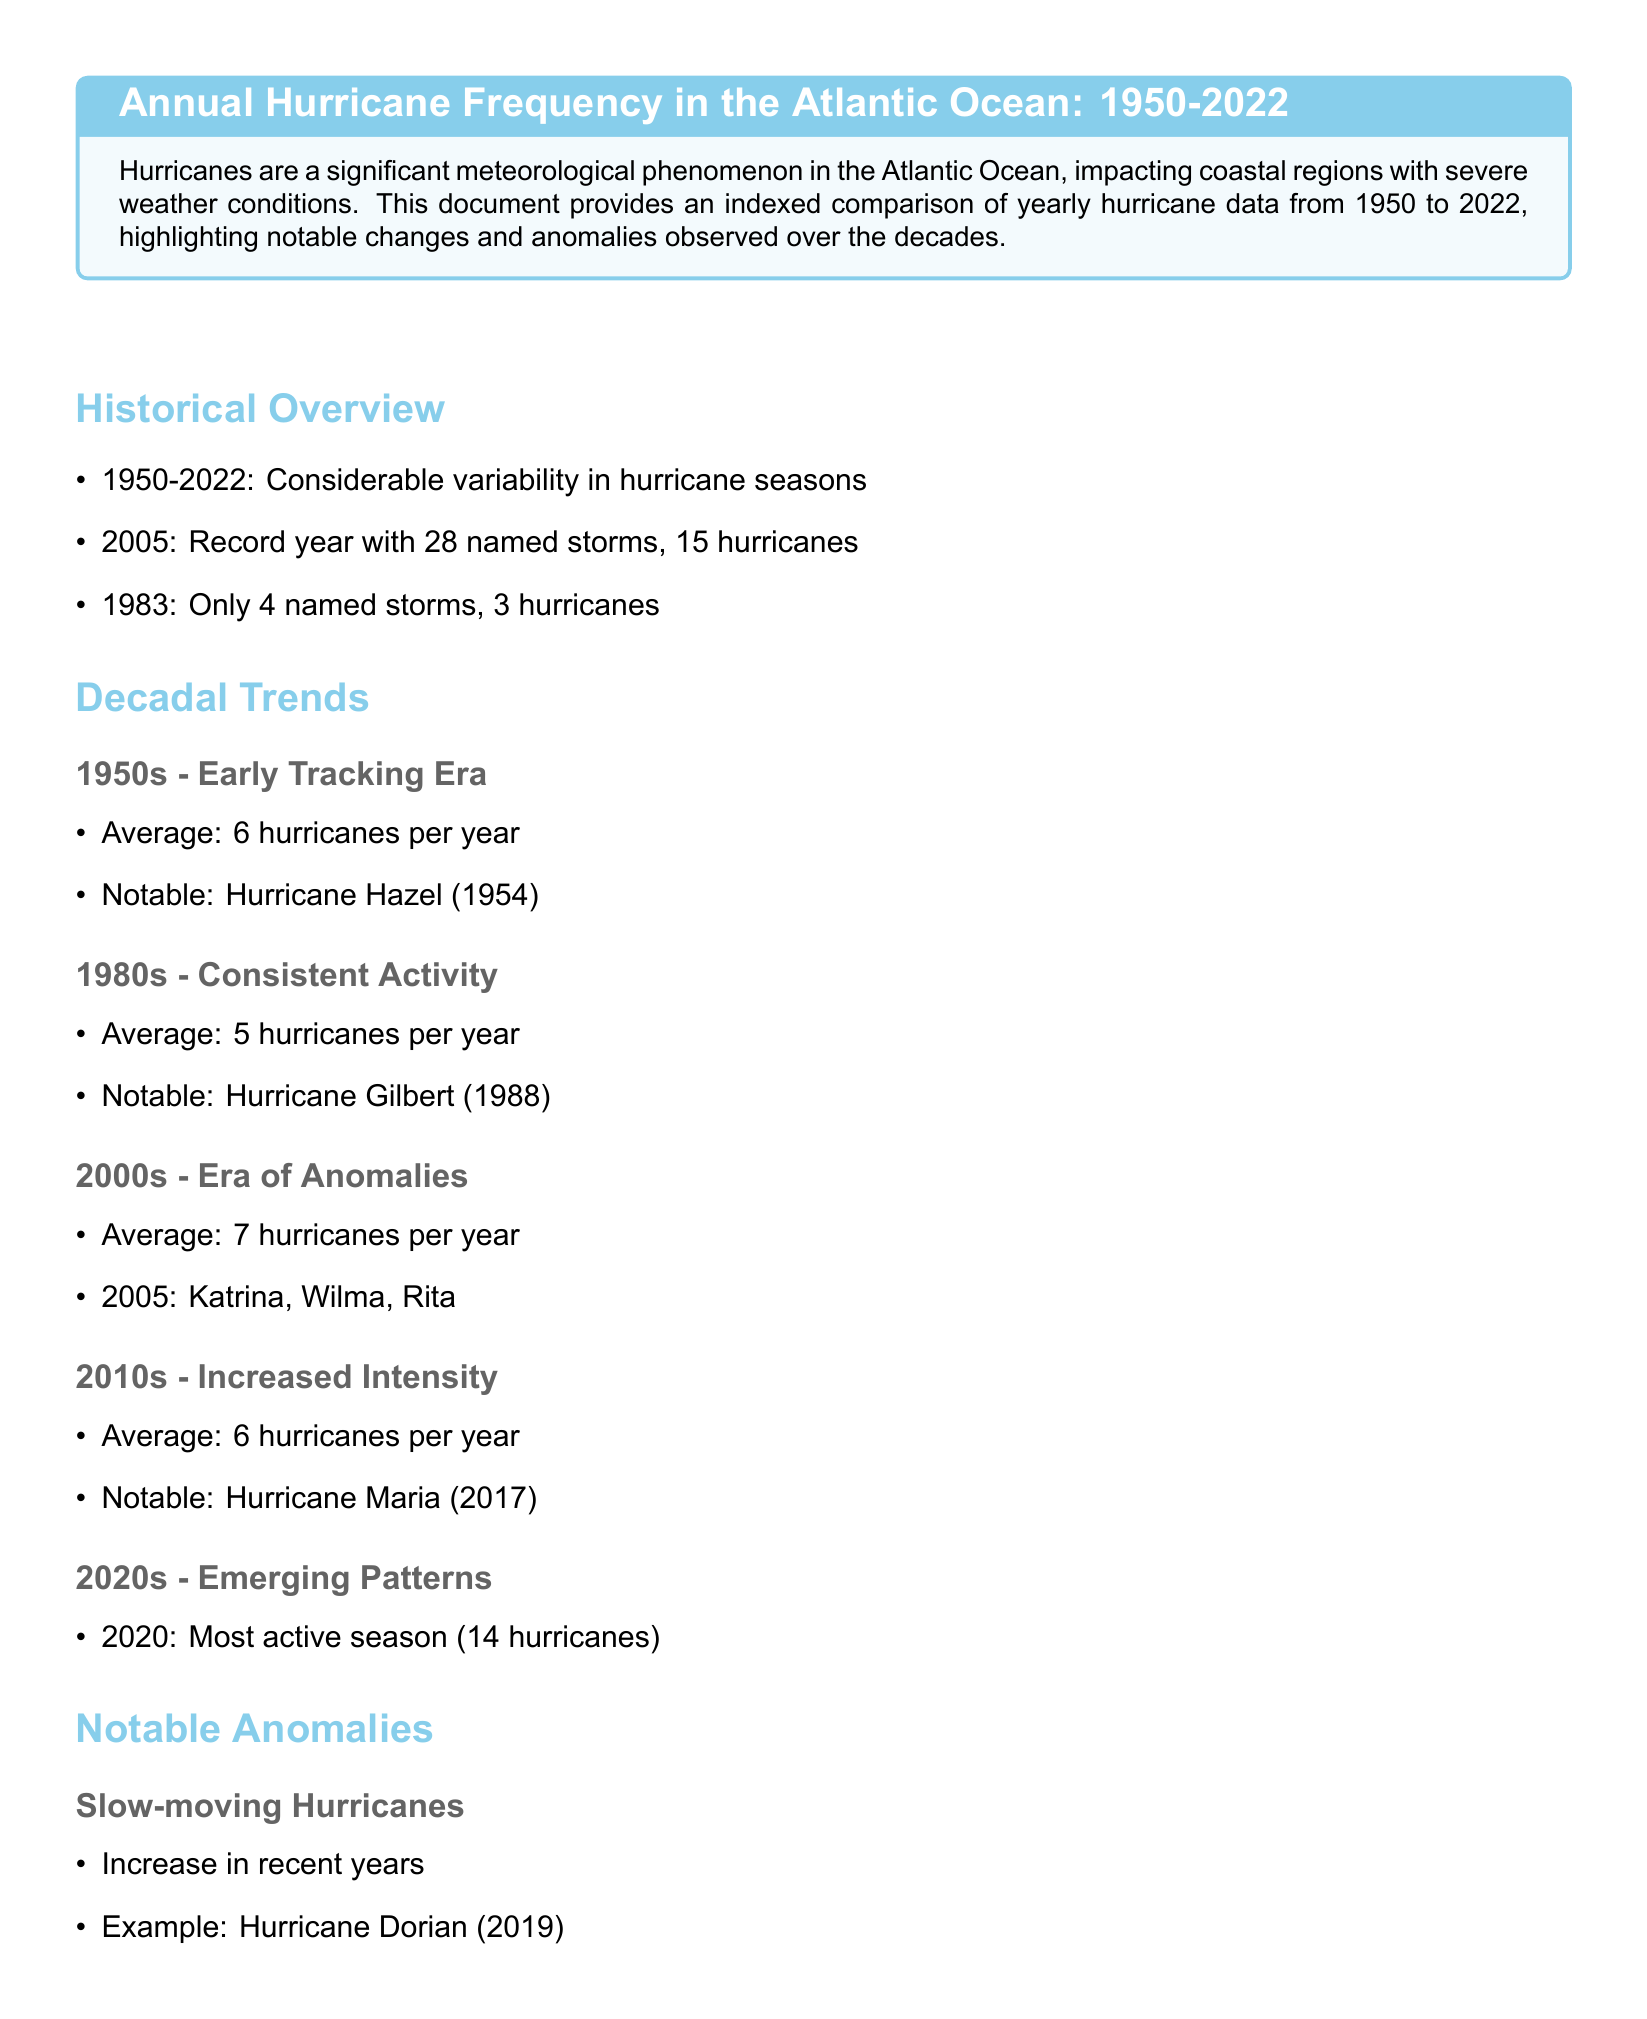What was the record year for named storms? The record year for named storms was 2005 with 28 named storms.
Answer: 2005 What was the average number of hurricanes per year in the 1950s? The average number of hurricanes per year in the 1950s was 6.
Answer: 6 Which hurricane is noted from the 1980s? The notable hurricane from the 1980s is Hurricane Gilbert (1988).
Answer: Hurricane Gilbert What notable hurricane occurred in 2017? The notable hurricane that occurred in 2017 is Hurricane Maria.
Answer: Hurricane Maria How many hurricanes were recorded in 2020? The number of hurricanes recorded in 2020 was 14.
Answer: 14 What anomaly was observed in recent years regarding hurricanes? An anomaly observed in recent years is the increase in slow-moving hurricanes.
Answer: Increase in slow-moving hurricanes What category are more recent hurricanes increasingly reaching? More recent hurricanes are increasingly reaching Category 5.
Answer: Category 5 Which hurricane is an example of increased intensity in 2018? An example of increased intensity in 2018 is Hurricane Michael.
Answer: Hurricane Michael What is the conclusion about the trends observed from 1950 to 2022? The conclusion states there is a clear pattern of increasing intensity and unprecedented activity.
Answer: Increasing intensity and unprecedented activity 